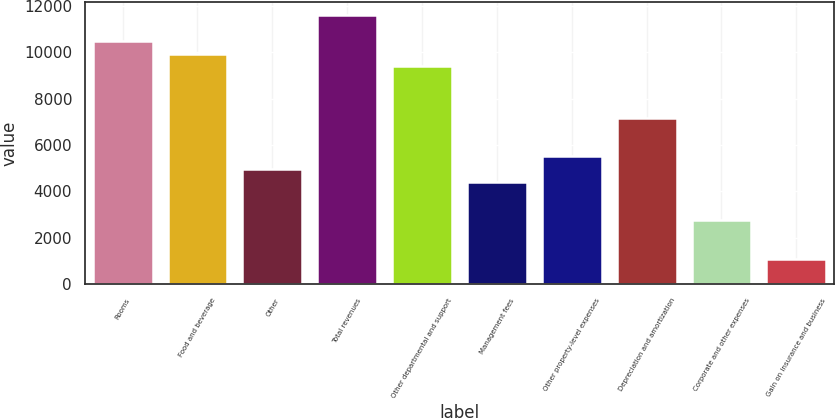<chart> <loc_0><loc_0><loc_500><loc_500><bar_chart><fcel>Rooms<fcel>Food and beverage<fcel>Other<fcel>Total revenues<fcel>Other departmental and support<fcel>Management fees<fcel>Other property-level expenses<fcel>Depreciation and amortization<fcel>Corporate and other expenses<fcel>Gain on insurance and business<nl><fcel>10494.2<fcel>9942<fcel>4971.75<fcel>11598.8<fcel>9389.75<fcel>4419.5<fcel>5524<fcel>7180.75<fcel>2762.75<fcel>1106<nl></chart> 